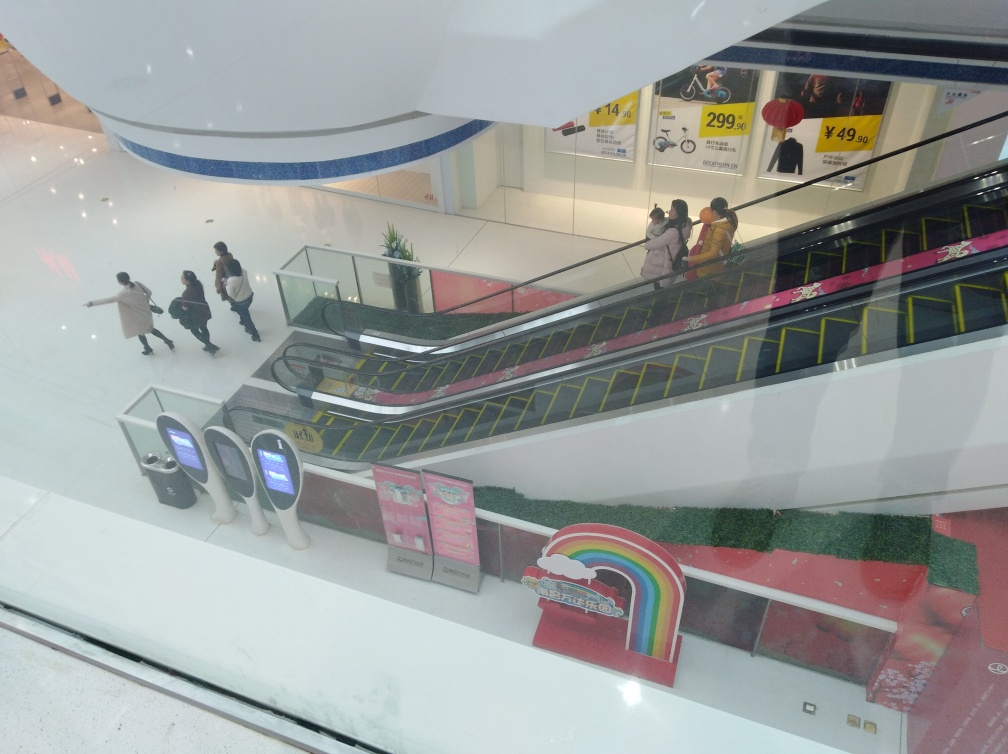Can you describe the activity going on in the image? In the image, we see several people in motion, using the escalator to move between floors of what appears to be a shopping center. A group is ascending on the escalator, while a few individuals are walking nearby, each engaged in their own activities, possibly shopping or simply transiting through the area. Does the setting look busy or crowded? Based on the snapshot provided, the setting does not appear to be excessively busy or crowded. There is a modest number of individuals present, suggesting a normal flow of foot traffic but without signs of congestion or overcrowding. This could imply a non-peak time of day or a relaxed day at the shopping center. 